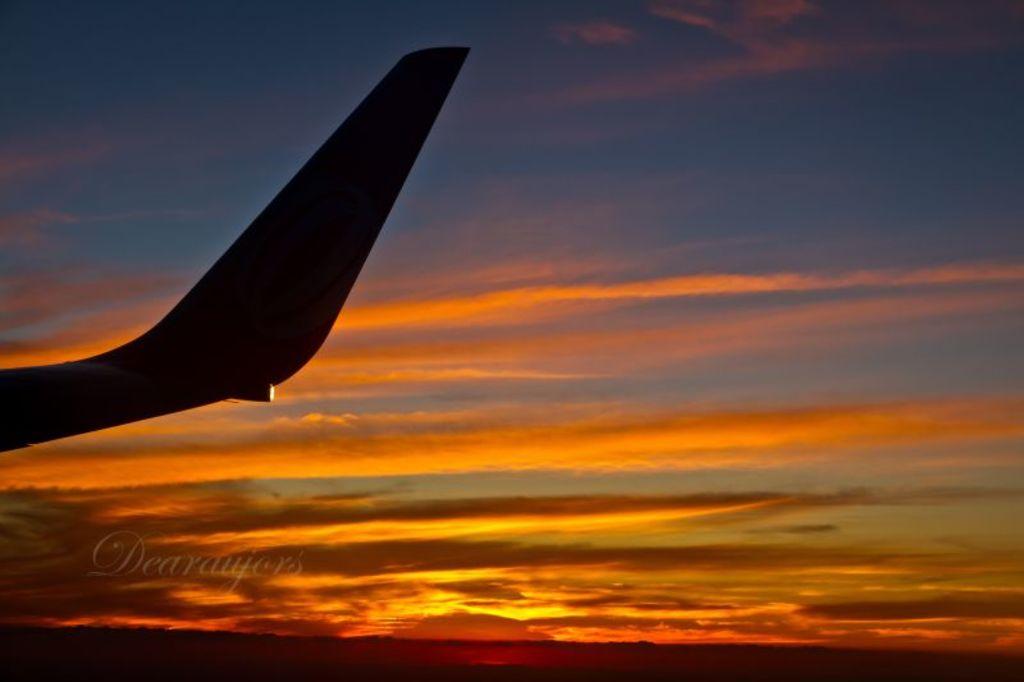Is it early sunrise?
Offer a very short reply. Yes. 